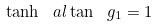<formula> <loc_0><loc_0><loc_500><loc_500>\tanh \ a l \tan \ g _ { 1 } = 1</formula> 